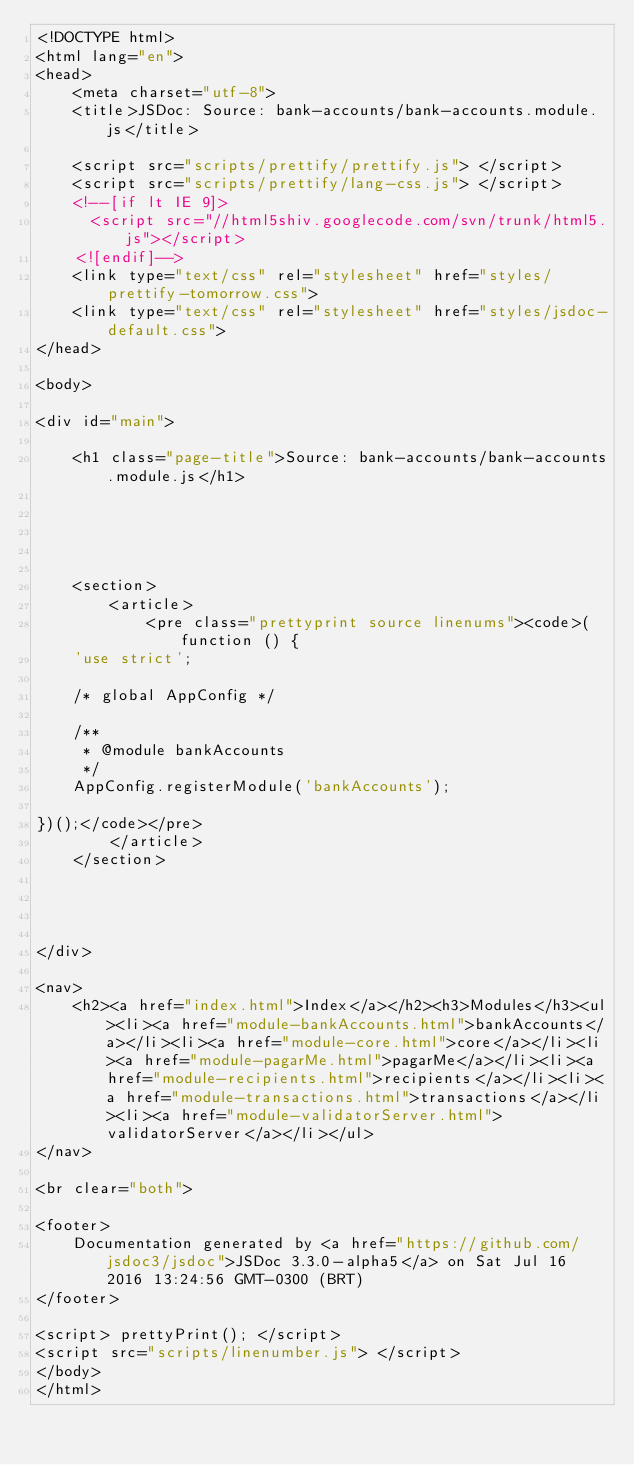Convert code to text. <code><loc_0><loc_0><loc_500><loc_500><_HTML_><!DOCTYPE html>
<html lang="en">
<head>
    <meta charset="utf-8">
    <title>JSDoc: Source: bank-accounts/bank-accounts.module.js</title>

    <script src="scripts/prettify/prettify.js"> </script>
    <script src="scripts/prettify/lang-css.js"> </script>
    <!--[if lt IE 9]>
      <script src="//html5shiv.googlecode.com/svn/trunk/html5.js"></script>
    <![endif]-->
    <link type="text/css" rel="stylesheet" href="styles/prettify-tomorrow.css">
    <link type="text/css" rel="stylesheet" href="styles/jsdoc-default.css">
</head>

<body>

<div id="main">

    <h1 class="page-title">Source: bank-accounts/bank-accounts.module.js</h1>

    


    
    <section>
        <article>
            <pre class="prettyprint source linenums"><code>(function () {
    'use strict';
    
    /* global AppConfig */
    
    /**
     * @module bankAccounts
     */
    AppConfig.registerModule('bankAccounts');

})();</code></pre>
        </article>
    </section>




</div>

<nav>
    <h2><a href="index.html">Index</a></h2><h3>Modules</h3><ul><li><a href="module-bankAccounts.html">bankAccounts</a></li><li><a href="module-core.html">core</a></li><li><a href="module-pagarMe.html">pagarMe</a></li><li><a href="module-recipients.html">recipients</a></li><li><a href="module-transactions.html">transactions</a></li><li><a href="module-validatorServer.html">validatorServer</a></li></ul>
</nav>

<br clear="both">

<footer>
    Documentation generated by <a href="https://github.com/jsdoc3/jsdoc">JSDoc 3.3.0-alpha5</a> on Sat Jul 16 2016 13:24:56 GMT-0300 (BRT)
</footer>

<script> prettyPrint(); </script>
<script src="scripts/linenumber.js"> </script>
</body>
</html>
</code> 